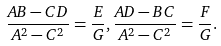<formula> <loc_0><loc_0><loc_500><loc_500>\frac { A B - C D } { A ^ { 2 } - C ^ { 2 } } = \frac { E } { G } , \frac { A D - B C } { A ^ { 2 } - C ^ { 2 } } = \frac { F } { G } .</formula> 